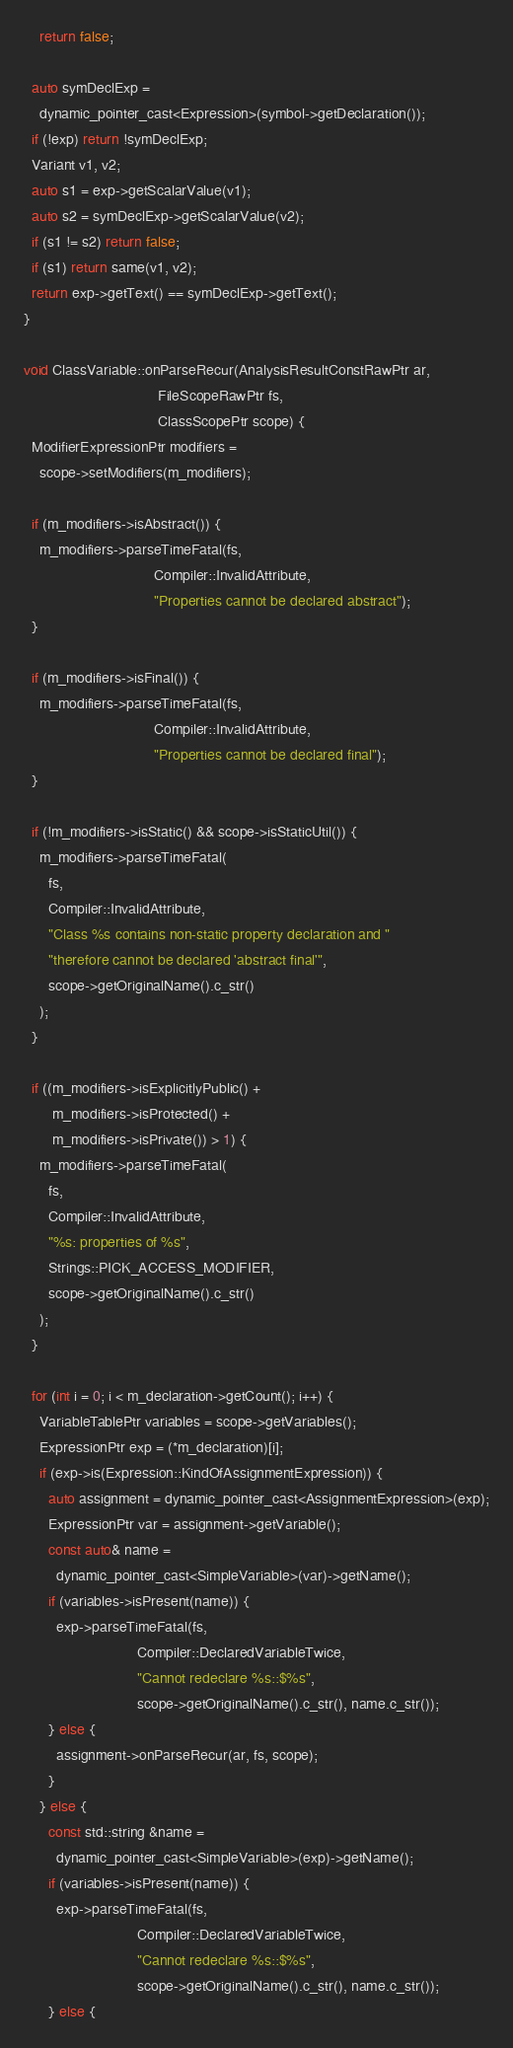<code> <loc_0><loc_0><loc_500><loc_500><_C++_>    return false;

  auto symDeclExp =
    dynamic_pointer_cast<Expression>(symbol->getDeclaration());
  if (!exp) return !symDeclExp;
  Variant v1, v2;
  auto s1 = exp->getScalarValue(v1);
  auto s2 = symDeclExp->getScalarValue(v2);
  if (s1 != s2) return false;
  if (s1) return same(v1, v2);
  return exp->getText() == symDeclExp->getText();
}

void ClassVariable::onParseRecur(AnalysisResultConstRawPtr ar,
                                 FileScopeRawPtr fs,
                                 ClassScopePtr scope) {
  ModifierExpressionPtr modifiers =
    scope->setModifiers(m_modifiers);

  if (m_modifiers->isAbstract()) {
    m_modifiers->parseTimeFatal(fs,
                                Compiler::InvalidAttribute,
                                "Properties cannot be declared abstract");
  }

  if (m_modifiers->isFinal()) {
    m_modifiers->parseTimeFatal(fs,
                                Compiler::InvalidAttribute,
                                "Properties cannot be declared final");
  }

  if (!m_modifiers->isStatic() && scope->isStaticUtil()) {
    m_modifiers->parseTimeFatal(
      fs,
      Compiler::InvalidAttribute,
      "Class %s contains non-static property declaration and "
      "therefore cannot be declared 'abstract final'",
      scope->getOriginalName().c_str()
    );
  }

  if ((m_modifiers->isExplicitlyPublic() +
       m_modifiers->isProtected() +
       m_modifiers->isPrivate()) > 1) {
    m_modifiers->parseTimeFatal(
      fs,
      Compiler::InvalidAttribute,
      "%s: properties of %s",
      Strings::PICK_ACCESS_MODIFIER,
      scope->getOriginalName().c_str()
    );
  }

  for (int i = 0; i < m_declaration->getCount(); i++) {
    VariableTablePtr variables = scope->getVariables();
    ExpressionPtr exp = (*m_declaration)[i];
    if (exp->is(Expression::KindOfAssignmentExpression)) {
      auto assignment = dynamic_pointer_cast<AssignmentExpression>(exp);
      ExpressionPtr var = assignment->getVariable();
      const auto& name =
        dynamic_pointer_cast<SimpleVariable>(var)->getName();
      if (variables->isPresent(name)) {
        exp->parseTimeFatal(fs,
                            Compiler::DeclaredVariableTwice,
                            "Cannot redeclare %s::$%s",
                            scope->getOriginalName().c_str(), name.c_str());
      } else {
        assignment->onParseRecur(ar, fs, scope);
      }
    } else {
      const std::string &name =
        dynamic_pointer_cast<SimpleVariable>(exp)->getName();
      if (variables->isPresent(name)) {
        exp->parseTimeFatal(fs,
                            Compiler::DeclaredVariableTwice,
                            "Cannot redeclare %s::$%s",
                            scope->getOriginalName().c_str(), name.c_str());
      } else {</code> 